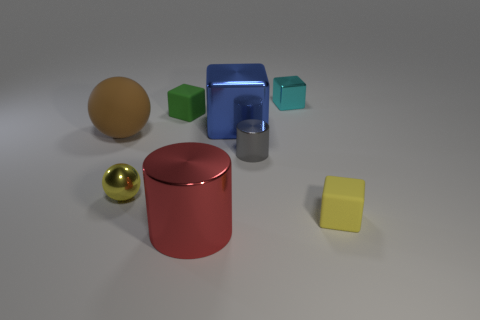Add 2 tiny yellow cubes. How many objects exist? 10 Subtract all balls. How many objects are left? 6 Subtract all big blue metallic blocks. Subtract all tiny yellow cubes. How many objects are left? 6 Add 5 gray things. How many gray things are left? 6 Add 6 metallic spheres. How many metallic spheres exist? 7 Subtract 0 green cylinders. How many objects are left? 8 